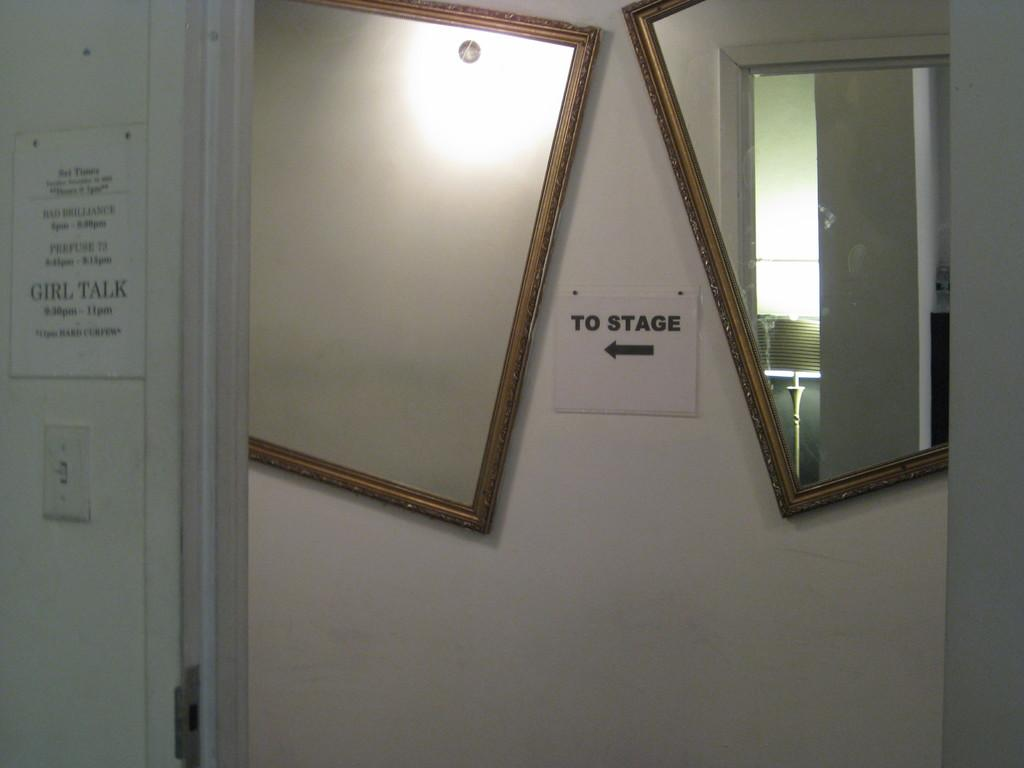How many mirrors are on the wall in the image? There are 2 mirrors on the wall in the image. What is located in the center of the image? There is a note in the center of the image. What can be found on the left side of the image? There is a switch and a note at the left side of the image. Can you hear the dog barking in the image? There is no dog present in the image, so it is not possible to hear a dog barking. Is there a chain hanging from the ceiling in the image? There is no chain visible in the image. 